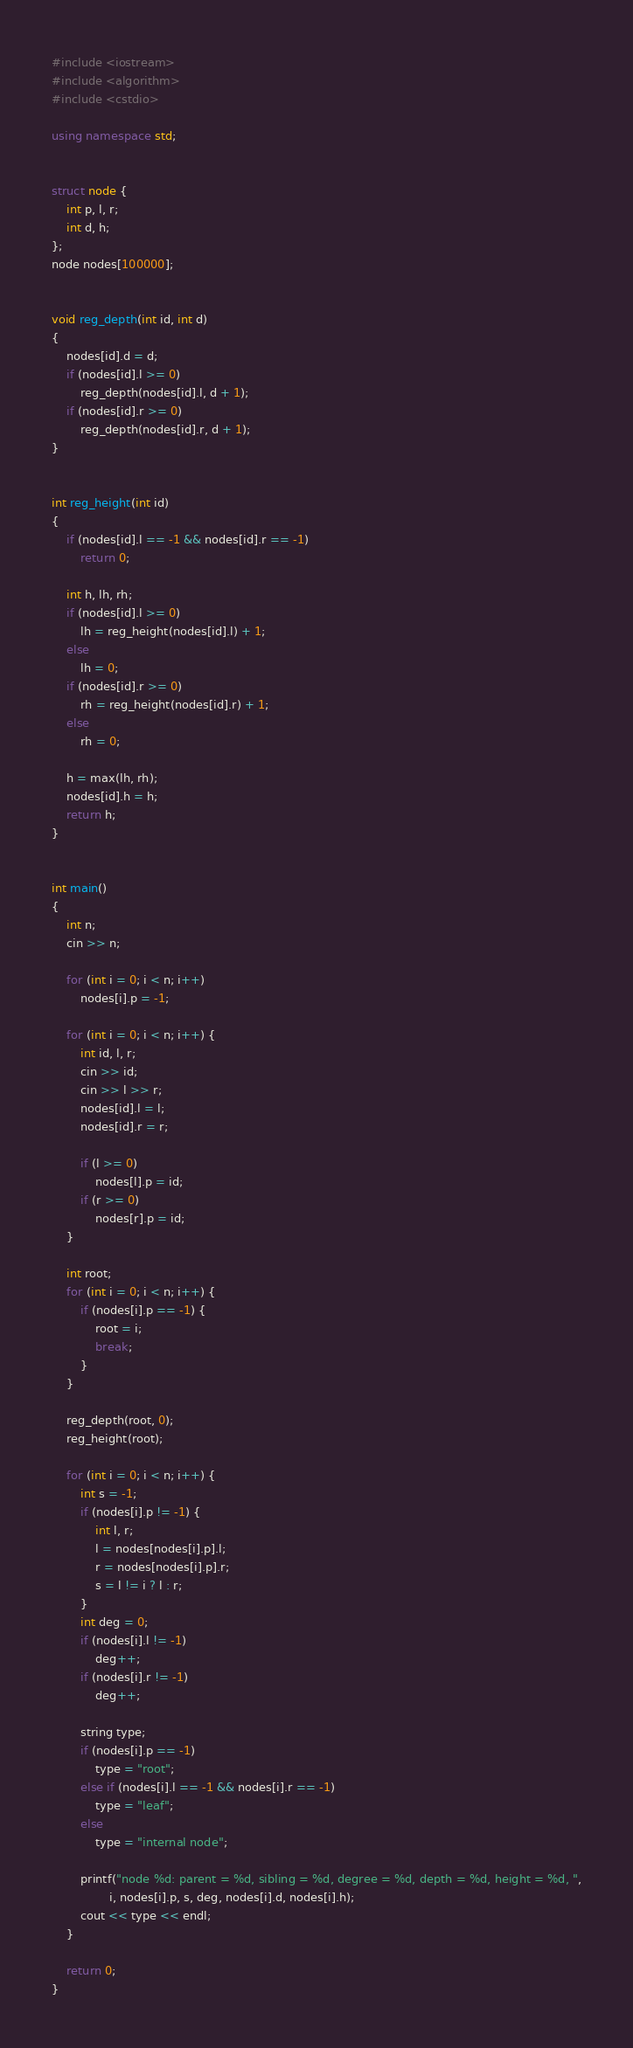Convert code to text. <code><loc_0><loc_0><loc_500><loc_500><_C++_>#include <iostream>
#include <algorithm>
#include <cstdio>

using namespace std;


struct node {
    int p, l, r;
    int d, h;
};
node nodes[100000];


void reg_depth(int id, int d)
{
    nodes[id].d = d;
    if (nodes[id].l >= 0)
        reg_depth(nodes[id].l, d + 1);
    if (nodes[id].r >= 0)
        reg_depth(nodes[id].r, d + 1);
}


int reg_height(int id)
{
    if (nodes[id].l == -1 && nodes[id].r == -1)
        return 0;

    int h, lh, rh;
    if (nodes[id].l >= 0)
        lh = reg_height(nodes[id].l) + 1;
    else
        lh = 0;
    if (nodes[id].r >= 0)
        rh = reg_height(nodes[id].r) + 1;
    else
        rh = 0;

    h = max(lh, rh);
    nodes[id].h = h;
    return h;
}


int main()
{
    int n;
    cin >> n;

    for (int i = 0; i < n; i++)
        nodes[i].p = -1;

    for (int i = 0; i < n; i++) {
        int id, l, r;
        cin >> id;
        cin >> l >> r;
        nodes[id].l = l;
        nodes[id].r = r;

        if (l >= 0)
            nodes[l].p = id;
        if (r >= 0)
            nodes[r].p = id;
    }

    int root;
    for (int i = 0; i < n; i++) {
        if (nodes[i].p == -1) {
            root = i;
            break;
        }
    }

    reg_depth(root, 0);
    reg_height(root);

    for (int i = 0; i < n; i++) {
        int s = -1;
        if (nodes[i].p != -1) {
            int l, r;
            l = nodes[nodes[i].p].l;
            r = nodes[nodes[i].p].r;
            s = l != i ? l : r;
        }
        int deg = 0;
        if (nodes[i].l != -1)
            deg++;
        if (nodes[i].r != -1)
            deg++;

        string type;
        if (nodes[i].p == -1)
            type = "root";
        else if (nodes[i].l == -1 && nodes[i].r == -1)
            type = "leaf";
        else
            type = "internal node";

        printf("node %d: parent = %d, sibling = %d, degree = %d, depth = %d, height = %d, ",
                i, nodes[i].p, s, deg, nodes[i].d, nodes[i].h);
        cout << type << endl;
    }

    return 0;
}
</code> 